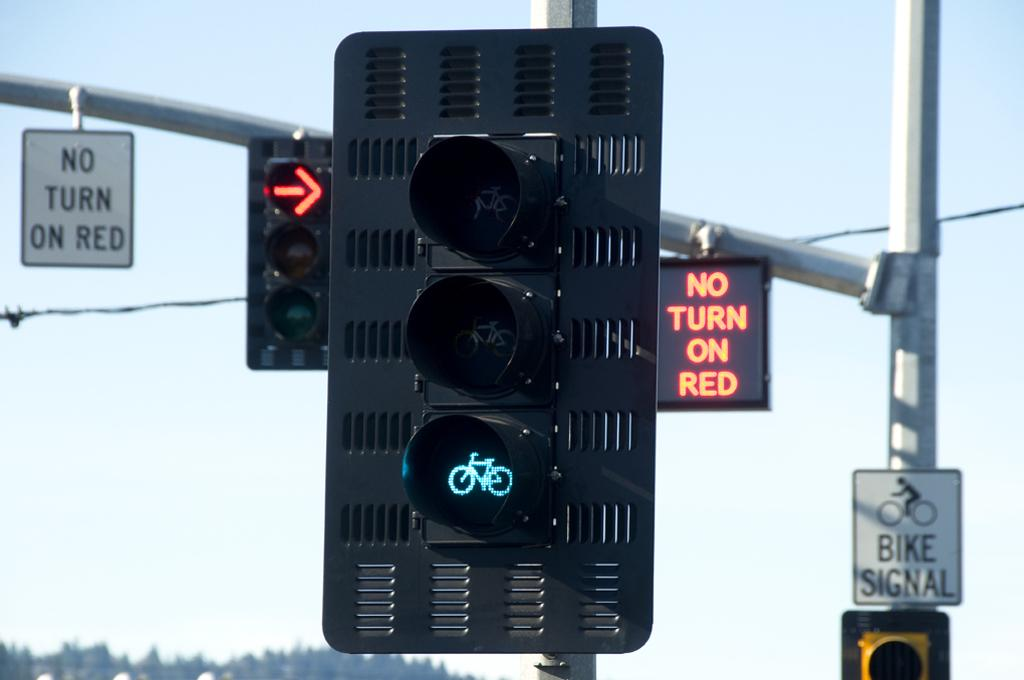What is attached to the pole in the image? There is a traffic light attached to a pole in the image, along with traffic lights and boards. What can be seen in the left bottom of the image? Trees are visible in the left bottom of the image. What is visible in the background of the image? The sky is visible in the background of the image. How many men are visible in the image? There are no men present in the image. Is it raining in the image? There is no indication of rain in the image. 